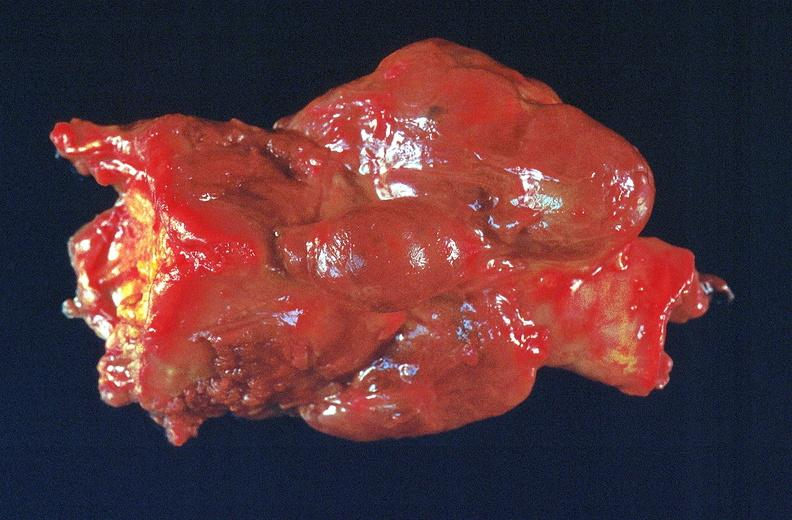does coronary artery show thyroid, goiter?
Answer the question using a single word or phrase. No 